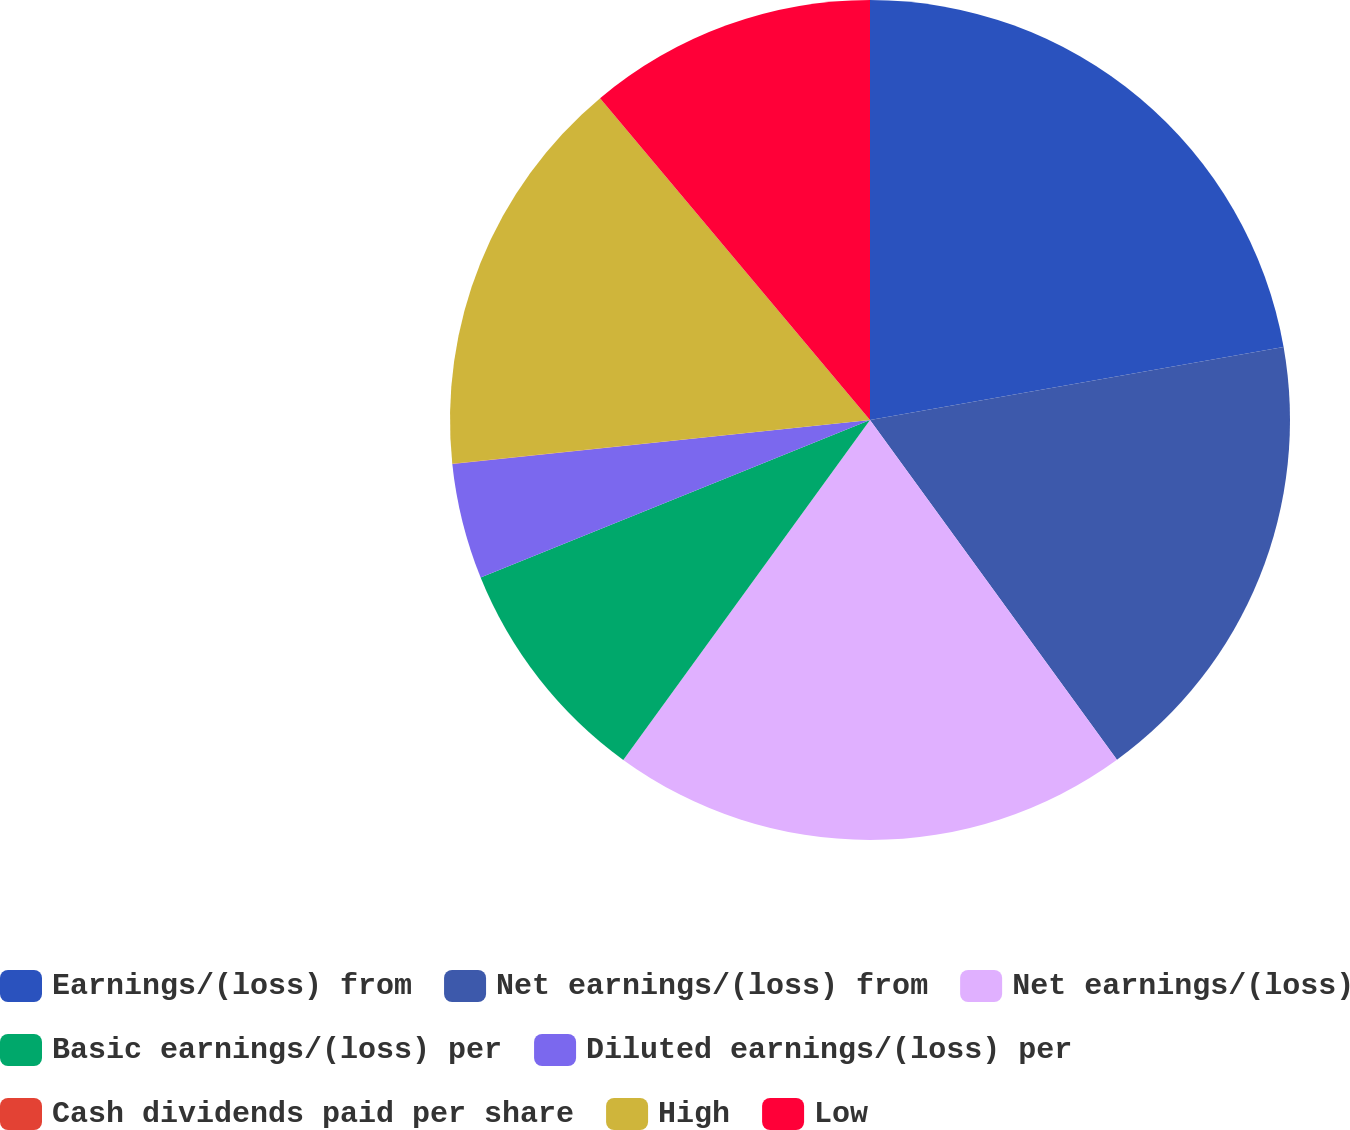<chart> <loc_0><loc_0><loc_500><loc_500><pie_chart><fcel>Earnings/(loss) from<fcel>Net earnings/(loss) from<fcel>Net earnings/(loss)<fcel>Basic earnings/(loss) per<fcel>Diluted earnings/(loss) per<fcel>Cash dividends paid per share<fcel>High<fcel>Low<nl><fcel>22.22%<fcel>17.78%<fcel>20.0%<fcel>8.89%<fcel>4.45%<fcel>0.01%<fcel>15.55%<fcel>11.11%<nl></chart> 